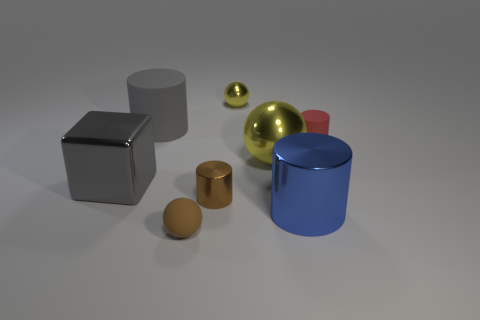There is a large metal object that is to the left of the large ball; what is its color? The large metal object to the left of the gold-colored ball appears to be silver or chrome, as it has a reflective surface that somewhat mirrors the environment. 